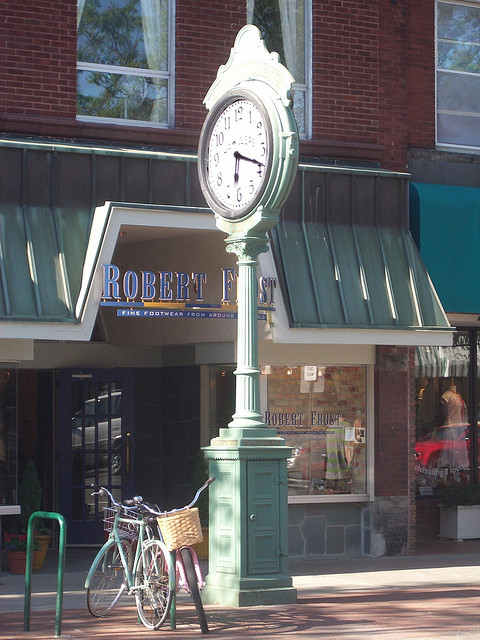<image>Who has the key to open the clock? It is unknown who has the key to open the clock. It could be 'city employees', 'Robert', 'owner', or 'maintenance'. Who has the key to open the clock? It is ambiguous who has the key to open the clock. It can be 'city', 'robert', 'owner', 'city employees', 'maintenance', or 'keeper'. 